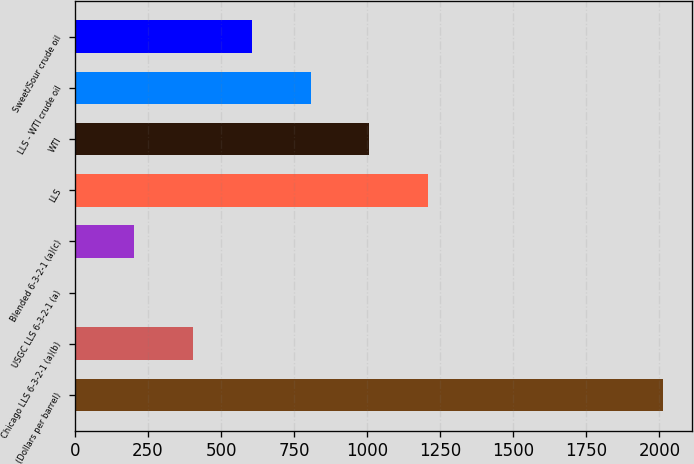Convert chart to OTSL. <chart><loc_0><loc_0><loc_500><loc_500><bar_chart><fcel>(Dollars per barrel)<fcel>Chicago LLS 6-3-2-1 (a)(b)<fcel>USGC LLS 6-3-2-1 (a)<fcel>Blended 6-3-2-1 (a)(c)<fcel>LLS<fcel>WTI<fcel>LLS - WTI crude oil<fcel>Sweet/Sour crude oil<nl><fcel>2011<fcel>404.48<fcel>2.84<fcel>203.66<fcel>1207.76<fcel>1006.94<fcel>806.12<fcel>605.3<nl></chart> 